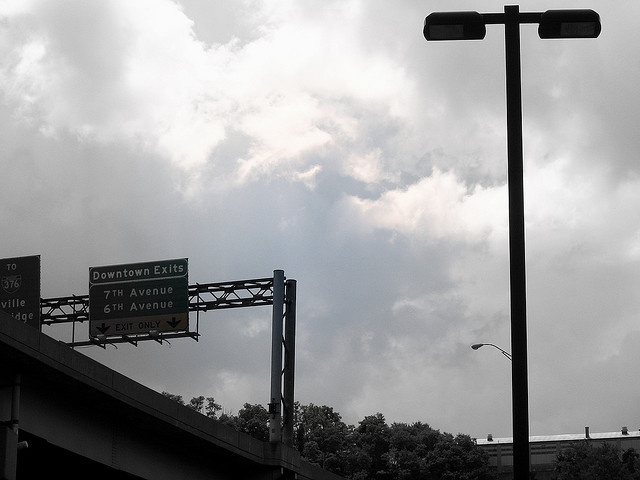Describe the objects in this image and their specific colors. I can see various objects in this image with different colors. 